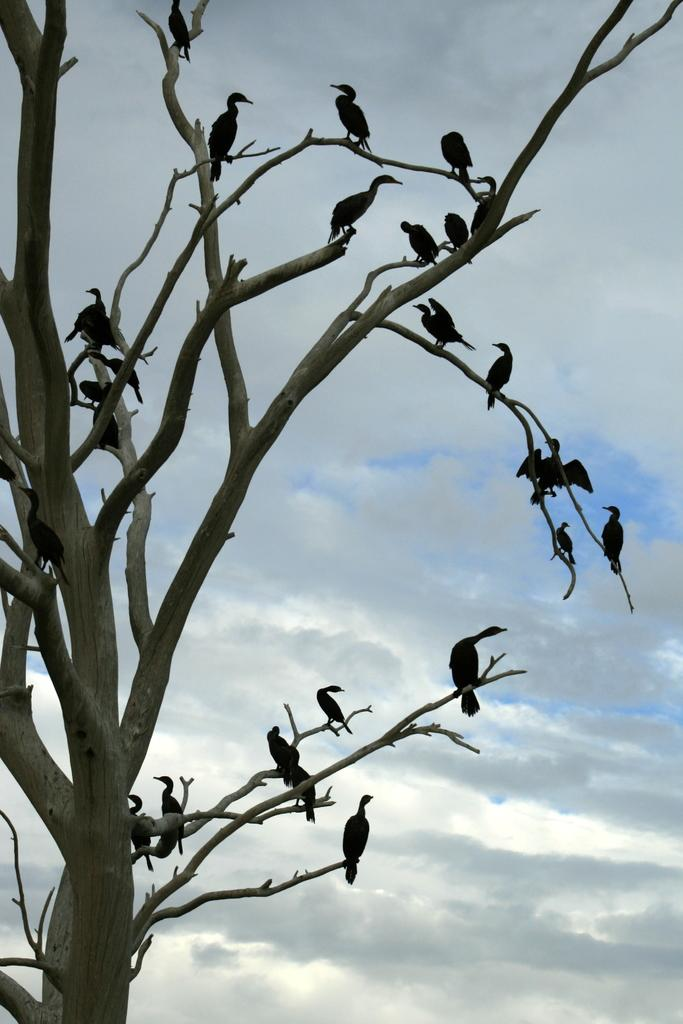What type of animals can be seen in the image? There are birds in the image. Where are the birds located in the image? The birds are on the branches of a tree. What can be seen in the background of the image? The sky is visible in the background of the image. What type of pest is the secretary dealing with in the image? There is no secretary or pest present in the image; it features birds on the branches of a tree with the sky visible in the background. 